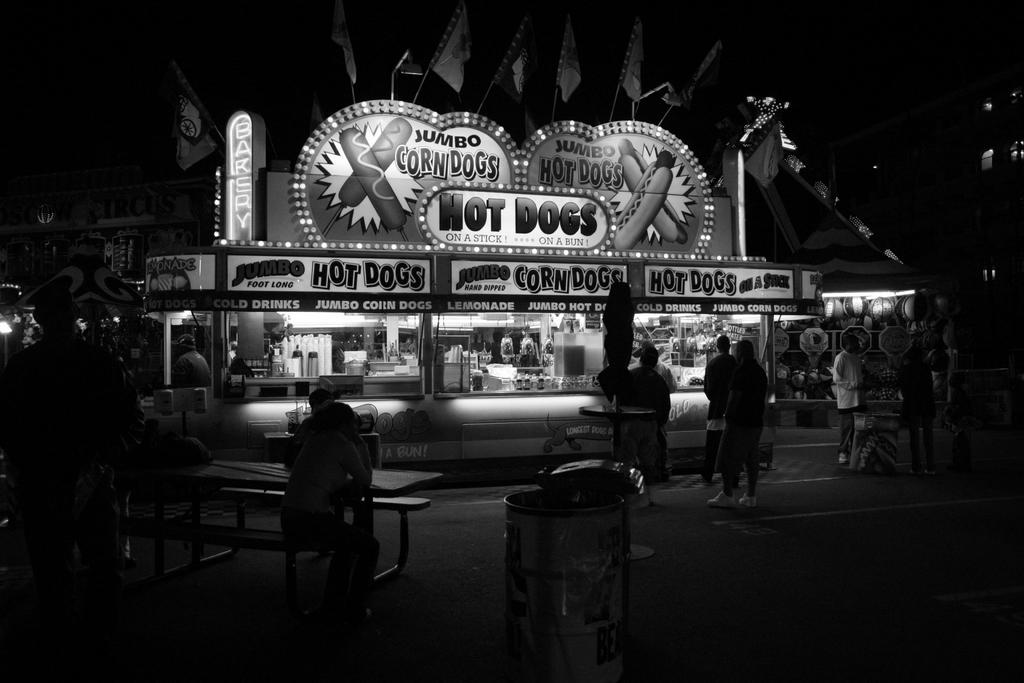What are they selling here?
Make the answer very short. Hot dogs. How many corn dogs are on the sign?
Provide a succinct answer. 2. 